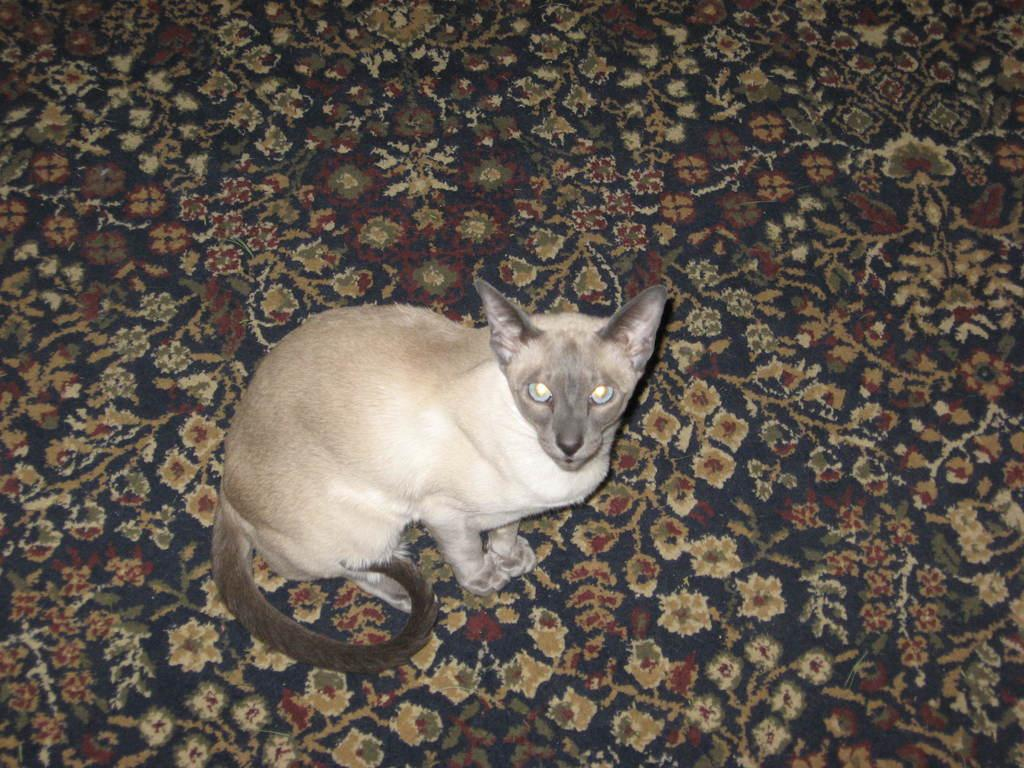What animal is in the image? There is a cat in the image. Where is the cat located in the image? The cat is in the center of the image. What surface is the cat on? The cat is on a carpet. What type of feeling does the cat have in the image? There is no indication of the cat's feelings in the image, as emotions cannot be determined from a still image. 